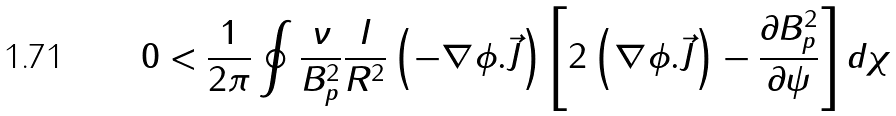Convert formula to latex. <formula><loc_0><loc_0><loc_500><loc_500>0 < \frac { 1 } { 2 \pi } \oint \frac { \nu } { B _ { p } ^ { 2 } } \frac { I } { R ^ { 2 } } \left ( - \nabla \phi . \vec { J } \right ) \left [ 2 \left ( \nabla \phi . \vec { J } \right ) - \frac { \partial B _ { p } ^ { 2 } } { \partial \psi } \right ] d \chi</formula> 